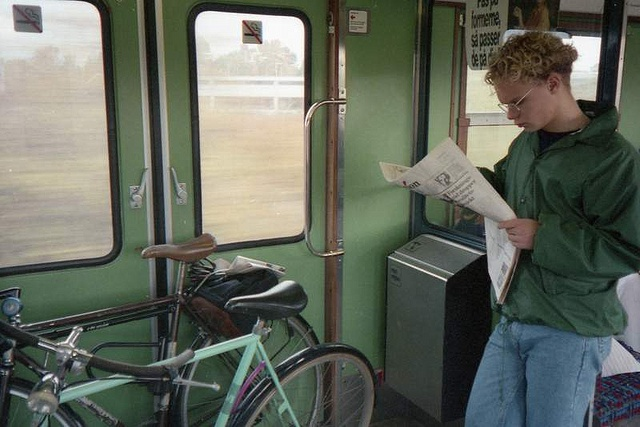Describe the objects in this image and their specific colors. I can see train in lightgray, gray, black, tan, and darkgray tones, people in lightgray, black, gray, blue, and darkgreen tones, bicycle in lightgray, gray, black, darkgray, and darkgreen tones, and bicycle in lightgray, black, gray, darkgreen, and darkgray tones in this image. 